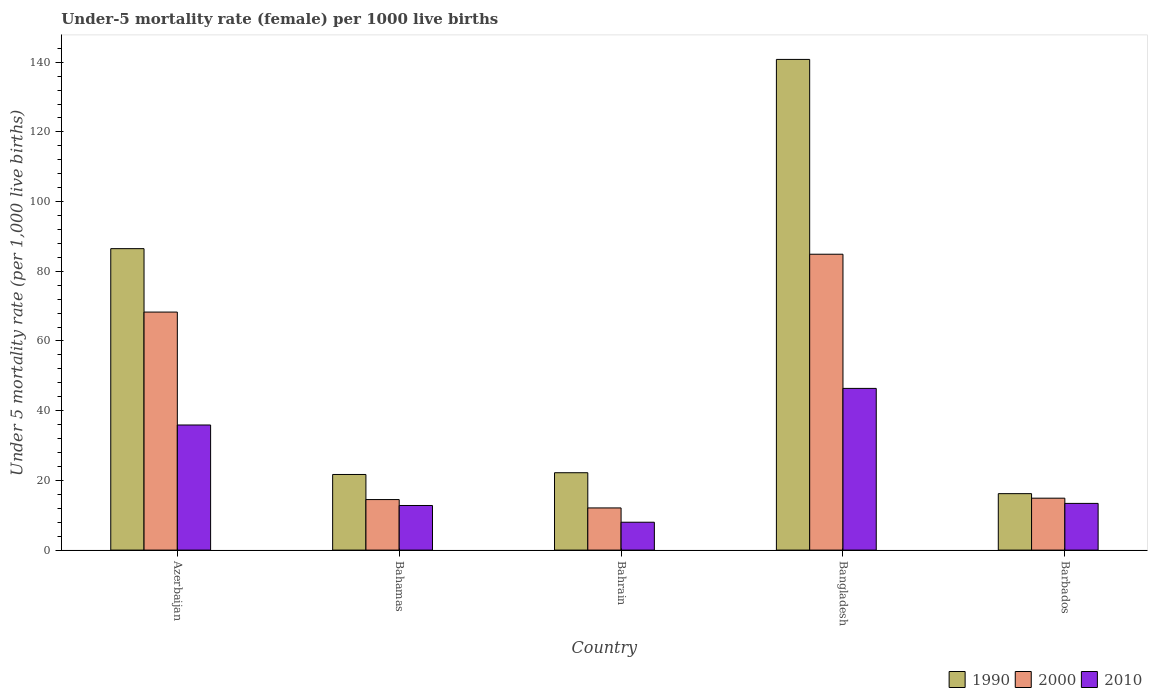How many different coloured bars are there?
Your answer should be compact. 3. How many groups of bars are there?
Your response must be concise. 5. What is the label of the 4th group of bars from the left?
Make the answer very short. Bangladesh. What is the under-five mortality rate in 2000 in Bahrain?
Offer a very short reply. 12.1. Across all countries, what is the maximum under-five mortality rate in 2010?
Make the answer very short. 46.4. In which country was the under-five mortality rate in 1990 maximum?
Your answer should be compact. Bangladesh. In which country was the under-five mortality rate in 1990 minimum?
Provide a succinct answer. Barbados. What is the total under-five mortality rate in 2000 in the graph?
Your answer should be compact. 194.7. What is the difference between the under-five mortality rate in 2010 in Bahamas and that in Bahrain?
Your answer should be very brief. 4.8. What is the difference between the under-five mortality rate in 2010 in Barbados and the under-five mortality rate in 2000 in Bangladesh?
Offer a very short reply. -71.5. What is the average under-five mortality rate in 2010 per country?
Your answer should be very brief. 23.3. What is the difference between the under-five mortality rate of/in 2000 and under-five mortality rate of/in 1990 in Barbados?
Offer a terse response. -1.3. In how many countries, is the under-five mortality rate in 2000 greater than 64?
Give a very brief answer. 2. What is the ratio of the under-five mortality rate in 2000 in Azerbaijan to that in Bahamas?
Make the answer very short. 4.71. What is the difference between the highest and the second highest under-five mortality rate in 2010?
Offer a very short reply. 22.5. What is the difference between the highest and the lowest under-five mortality rate in 2000?
Offer a very short reply. 72.8. Is the sum of the under-five mortality rate in 2010 in Bahrain and Bangladesh greater than the maximum under-five mortality rate in 2000 across all countries?
Your answer should be compact. No. What does the 3rd bar from the left in Bahrain represents?
Keep it short and to the point. 2010. Is it the case that in every country, the sum of the under-five mortality rate in 2010 and under-five mortality rate in 2000 is greater than the under-five mortality rate in 1990?
Your answer should be very brief. No. Are all the bars in the graph horizontal?
Your answer should be compact. No. How many countries are there in the graph?
Your answer should be very brief. 5. Are the values on the major ticks of Y-axis written in scientific E-notation?
Provide a short and direct response. No. Where does the legend appear in the graph?
Keep it short and to the point. Bottom right. How are the legend labels stacked?
Your response must be concise. Horizontal. What is the title of the graph?
Offer a terse response. Under-5 mortality rate (female) per 1000 live births. Does "1983" appear as one of the legend labels in the graph?
Offer a terse response. No. What is the label or title of the X-axis?
Your answer should be very brief. Country. What is the label or title of the Y-axis?
Make the answer very short. Under 5 mortality rate (per 1,0 live births). What is the Under 5 mortality rate (per 1,000 live births) in 1990 in Azerbaijan?
Provide a succinct answer. 86.5. What is the Under 5 mortality rate (per 1,000 live births) of 2000 in Azerbaijan?
Your answer should be compact. 68.3. What is the Under 5 mortality rate (per 1,000 live births) of 2010 in Azerbaijan?
Your response must be concise. 35.9. What is the Under 5 mortality rate (per 1,000 live births) in 1990 in Bahamas?
Your answer should be very brief. 21.7. What is the Under 5 mortality rate (per 1,000 live births) in 1990 in Bahrain?
Offer a terse response. 22.2. What is the Under 5 mortality rate (per 1,000 live births) of 2000 in Bahrain?
Your answer should be compact. 12.1. What is the Under 5 mortality rate (per 1,000 live births) in 2010 in Bahrain?
Give a very brief answer. 8. What is the Under 5 mortality rate (per 1,000 live births) in 1990 in Bangladesh?
Your answer should be very brief. 140.8. What is the Under 5 mortality rate (per 1,000 live births) in 2000 in Bangladesh?
Your response must be concise. 84.9. What is the Under 5 mortality rate (per 1,000 live births) of 2010 in Bangladesh?
Your response must be concise. 46.4. What is the Under 5 mortality rate (per 1,000 live births) in 1990 in Barbados?
Keep it short and to the point. 16.2. What is the Under 5 mortality rate (per 1,000 live births) in 2010 in Barbados?
Offer a very short reply. 13.4. Across all countries, what is the maximum Under 5 mortality rate (per 1,000 live births) in 1990?
Your answer should be very brief. 140.8. Across all countries, what is the maximum Under 5 mortality rate (per 1,000 live births) of 2000?
Ensure brevity in your answer.  84.9. Across all countries, what is the maximum Under 5 mortality rate (per 1,000 live births) in 2010?
Your answer should be compact. 46.4. Across all countries, what is the minimum Under 5 mortality rate (per 1,000 live births) of 1990?
Keep it short and to the point. 16.2. What is the total Under 5 mortality rate (per 1,000 live births) of 1990 in the graph?
Keep it short and to the point. 287.4. What is the total Under 5 mortality rate (per 1,000 live births) of 2000 in the graph?
Offer a terse response. 194.7. What is the total Under 5 mortality rate (per 1,000 live births) of 2010 in the graph?
Ensure brevity in your answer.  116.5. What is the difference between the Under 5 mortality rate (per 1,000 live births) of 1990 in Azerbaijan and that in Bahamas?
Your response must be concise. 64.8. What is the difference between the Under 5 mortality rate (per 1,000 live births) of 2000 in Azerbaijan and that in Bahamas?
Your response must be concise. 53.8. What is the difference between the Under 5 mortality rate (per 1,000 live births) of 2010 in Azerbaijan and that in Bahamas?
Ensure brevity in your answer.  23.1. What is the difference between the Under 5 mortality rate (per 1,000 live births) of 1990 in Azerbaijan and that in Bahrain?
Offer a terse response. 64.3. What is the difference between the Under 5 mortality rate (per 1,000 live births) of 2000 in Azerbaijan and that in Bahrain?
Provide a short and direct response. 56.2. What is the difference between the Under 5 mortality rate (per 1,000 live births) in 2010 in Azerbaijan and that in Bahrain?
Offer a very short reply. 27.9. What is the difference between the Under 5 mortality rate (per 1,000 live births) in 1990 in Azerbaijan and that in Bangladesh?
Keep it short and to the point. -54.3. What is the difference between the Under 5 mortality rate (per 1,000 live births) of 2000 in Azerbaijan and that in Bangladesh?
Provide a short and direct response. -16.6. What is the difference between the Under 5 mortality rate (per 1,000 live births) in 1990 in Azerbaijan and that in Barbados?
Your answer should be very brief. 70.3. What is the difference between the Under 5 mortality rate (per 1,000 live births) in 2000 in Azerbaijan and that in Barbados?
Your answer should be very brief. 53.4. What is the difference between the Under 5 mortality rate (per 1,000 live births) in 1990 in Bahamas and that in Bangladesh?
Provide a succinct answer. -119.1. What is the difference between the Under 5 mortality rate (per 1,000 live births) of 2000 in Bahamas and that in Bangladesh?
Give a very brief answer. -70.4. What is the difference between the Under 5 mortality rate (per 1,000 live births) of 2010 in Bahamas and that in Bangladesh?
Make the answer very short. -33.6. What is the difference between the Under 5 mortality rate (per 1,000 live births) in 1990 in Bahamas and that in Barbados?
Your response must be concise. 5.5. What is the difference between the Under 5 mortality rate (per 1,000 live births) of 2000 in Bahamas and that in Barbados?
Offer a terse response. -0.4. What is the difference between the Under 5 mortality rate (per 1,000 live births) in 2010 in Bahamas and that in Barbados?
Make the answer very short. -0.6. What is the difference between the Under 5 mortality rate (per 1,000 live births) in 1990 in Bahrain and that in Bangladesh?
Ensure brevity in your answer.  -118.6. What is the difference between the Under 5 mortality rate (per 1,000 live births) in 2000 in Bahrain and that in Bangladesh?
Your answer should be compact. -72.8. What is the difference between the Under 5 mortality rate (per 1,000 live births) of 2010 in Bahrain and that in Bangladesh?
Keep it short and to the point. -38.4. What is the difference between the Under 5 mortality rate (per 1,000 live births) in 1990 in Bahrain and that in Barbados?
Make the answer very short. 6. What is the difference between the Under 5 mortality rate (per 1,000 live births) of 2010 in Bahrain and that in Barbados?
Keep it short and to the point. -5.4. What is the difference between the Under 5 mortality rate (per 1,000 live births) of 1990 in Bangladesh and that in Barbados?
Your answer should be very brief. 124.6. What is the difference between the Under 5 mortality rate (per 1,000 live births) of 2000 in Bangladesh and that in Barbados?
Your answer should be compact. 70. What is the difference between the Under 5 mortality rate (per 1,000 live births) in 1990 in Azerbaijan and the Under 5 mortality rate (per 1,000 live births) in 2000 in Bahamas?
Offer a very short reply. 72. What is the difference between the Under 5 mortality rate (per 1,000 live births) of 1990 in Azerbaijan and the Under 5 mortality rate (per 1,000 live births) of 2010 in Bahamas?
Provide a succinct answer. 73.7. What is the difference between the Under 5 mortality rate (per 1,000 live births) of 2000 in Azerbaijan and the Under 5 mortality rate (per 1,000 live births) of 2010 in Bahamas?
Provide a short and direct response. 55.5. What is the difference between the Under 5 mortality rate (per 1,000 live births) in 1990 in Azerbaijan and the Under 5 mortality rate (per 1,000 live births) in 2000 in Bahrain?
Make the answer very short. 74.4. What is the difference between the Under 5 mortality rate (per 1,000 live births) in 1990 in Azerbaijan and the Under 5 mortality rate (per 1,000 live births) in 2010 in Bahrain?
Your response must be concise. 78.5. What is the difference between the Under 5 mortality rate (per 1,000 live births) of 2000 in Azerbaijan and the Under 5 mortality rate (per 1,000 live births) of 2010 in Bahrain?
Keep it short and to the point. 60.3. What is the difference between the Under 5 mortality rate (per 1,000 live births) in 1990 in Azerbaijan and the Under 5 mortality rate (per 1,000 live births) in 2010 in Bangladesh?
Make the answer very short. 40.1. What is the difference between the Under 5 mortality rate (per 1,000 live births) of 2000 in Azerbaijan and the Under 5 mortality rate (per 1,000 live births) of 2010 in Bangladesh?
Your response must be concise. 21.9. What is the difference between the Under 5 mortality rate (per 1,000 live births) in 1990 in Azerbaijan and the Under 5 mortality rate (per 1,000 live births) in 2000 in Barbados?
Ensure brevity in your answer.  71.6. What is the difference between the Under 5 mortality rate (per 1,000 live births) in 1990 in Azerbaijan and the Under 5 mortality rate (per 1,000 live births) in 2010 in Barbados?
Your answer should be very brief. 73.1. What is the difference between the Under 5 mortality rate (per 1,000 live births) in 2000 in Azerbaijan and the Under 5 mortality rate (per 1,000 live births) in 2010 in Barbados?
Give a very brief answer. 54.9. What is the difference between the Under 5 mortality rate (per 1,000 live births) in 1990 in Bahamas and the Under 5 mortality rate (per 1,000 live births) in 2000 in Bahrain?
Give a very brief answer. 9.6. What is the difference between the Under 5 mortality rate (per 1,000 live births) of 1990 in Bahamas and the Under 5 mortality rate (per 1,000 live births) of 2000 in Bangladesh?
Your response must be concise. -63.2. What is the difference between the Under 5 mortality rate (per 1,000 live births) of 1990 in Bahamas and the Under 5 mortality rate (per 1,000 live births) of 2010 in Bangladesh?
Your answer should be very brief. -24.7. What is the difference between the Under 5 mortality rate (per 1,000 live births) in 2000 in Bahamas and the Under 5 mortality rate (per 1,000 live births) in 2010 in Bangladesh?
Your answer should be compact. -31.9. What is the difference between the Under 5 mortality rate (per 1,000 live births) of 1990 in Bahamas and the Under 5 mortality rate (per 1,000 live births) of 2000 in Barbados?
Your answer should be very brief. 6.8. What is the difference between the Under 5 mortality rate (per 1,000 live births) of 2000 in Bahamas and the Under 5 mortality rate (per 1,000 live births) of 2010 in Barbados?
Ensure brevity in your answer.  1.1. What is the difference between the Under 5 mortality rate (per 1,000 live births) in 1990 in Bahrain and the Under 5 mortality rate (per 1,000 live births) in 2000 in Bangladesh?
Your answer should be very brief. -62.7. What is the difference between the Under 5 mortality rate (per 1,000 live births) in 1990 in Bahrain and the Under 5 mortality rate (per 1,000 live births) in 2010 in Bangladesh?
Keep it short and to the point. -24.2. What is the difference between the Under 5 mortality rate (per 1,000 live births) of 2000 in Bahrain and the Under 5 mortality rate (per 1,000 live births) of 2010 in Bangladesh?
Make the answer very short. -34.3. What is the difference between the Under 5 mortality rate (per 1,000 live births) of 1990 in Bahrain and the Under 5 mortality rate (per 1,000 live births) of 2000 in Barbados?
Ensure brevity in your answer.  7.3. What is the difference between the Under 5 mortality rate (per 1,000 live births) in 1990 in Bahrain and the Under 5 mortality rate (per 1,000 live births) in 2010 in Barbados?
Offer a very short reply. 8.8. What is the difference between the Under 5 mortality rate (per 1,000 live births) of 1990 in Bangladesh and the Under 5 mortality rate (per 1,000 live births) of 2000 in Barbados?
Provide a succinct answer. 125.9. What is the difference between the Under 5 mortality rate (per 1,000 live births) of 1990 in Bangladesh and the Under 5 mortality rate (per 1,000 live births) of 2010 in Barbados?
Offer a terse response. 127.4. What is the difference between the Under 5 mortality rate (per 1,000 live births) in 2000 in Bangladesh and the Under 5 mortality rate (per 1,000 live births) in 2010 in Barbados?
Keep it short and to the point. 71.5. What is the average Under 5 mortality rate (per 1,000 live births) in 1990 per country?
Make the answer very short. 57.48. What is the average Under 5 mortality rate (per 1,000 live births) in 2000 per country?
Your response must be concise. 38.94. What is the average Under 5 mortality rate (per 1,000 live births) of 2010 per country?
Provide a short and direct response. 23.3. What is the difference between the Under 5 mortality rate (per 1,000 live births) of 1990 and Under 5 mortality rate (per 1,000 live births) of 2010 in Azerbaijan?
Offer a very short reply. 50.6. What is the difference between the Under 5 mortality rate (per 1,000 live births) in 2000 and Under 5 mortality rate (per 1,000 live births) in 2010 in Azerbaijan?
Provide a short and direct response. 32.4. What is the difference between the Under 5 mortality rate (per 1,000 live births) of 1990 and Under 5 mortality rate (per 1,000 live births) of 2000 in Bahamas?
Your response must be concise. 7.2. What is the difference between the Under 5 mortality rate (per 1,000 live births) of 1990 and Under 5 mortality rate (per 1,000 live births) of 2010 in Bahamas?
Provide a succinct answer. 8.9. What is the difference between the Under 5 mortality rate (per 1,000 live births) in 2000 and Under 5 mortality rate (per 1,000 live births) in 2010 in Bahamas?
Provide a succinct answer. 1.7. What is the difference between the Under 5 mortality rate (per 1,000 live births) in 1990 and Under 5 mortality rate (per 1,000 live births) in 2010 in Bahrain?
Ensure brevity in your answer.  14.2. What is the difference between the Under 5 mortality rate (per 1,000 live births) of 2000 and Under 5 mortality rate (per 1,000 live births) of 2010 in Bahrain?
Offer a terse response. 4.1. What is the difference between the Under 5 mortality rate (per 1,000 live births) of 1990 and Under 5 mortality rate (per 1,000 live births) of 2000 in Bangladesh?
Offer a very short reply. 55.9. What is the difference between the Under 5 mortality rate (per 1,000 live births) in 1990 and Under 5 mortality rate (per 1,000 live births) in 2010 in Bangladesh?
Offer a very short reply. 94.4. What is the difference between the Under 5 mortality rate (per 1,000 live births) of 2000 and Under 5 mortality rate (per 1,000 live births) of 2010 in Bangladesh?
Your answer should be very brief. 38.5. What is the difference between the Under 5 mortality rate (per 1,000 live births) in 1990 and Under 5 mortality rate (per 1,000 live births) in 2010 in Barbados?
Make the answer very short. 2.8. What is the ratio of the Under 5 mortality rate (per 1,000 live births) in 1990 in Azerbaijan to that in Bahamas?
Your response must be concise. 3.99. What is the ratio of the Under 5 mortality rate (per 1,000 live births) in 2000 in Azerbaijan to that in Bahamas?
Offer a very short reply. 4.71. What is the ratio of the Under 5 mortality rate (per 1,000 live births) of 2010 in Azerbaijan to that in Bahamas?
Make the answer very short. 2.8. What is the ratio of the Under 5 mortality rate (per 1,000 live births) of 1990 in Azerbaijan to that in Bahrain?
Give a very brief answer. 3.9. What is the ratio of the Under 5 mortality rate (per 1,000 live births) of 2000 in Azerbaijan to that in Bahrain?
Give a very brief answer. 5.64. What is the ratio of the Under 5 mortality rate (per 1,000 live births) in 2010 in Azerbaijan to that in Bahrain?
Keep it short and to the point. 4.49. What is the ratio of the Under 5 mortality rate (per 1,000 live births) of 1990 in Azerbaijan to that in Bangladesh?
Provide a short and direct response. 0.61. What is the ratio of the Under 5 mortality rate (per 1,000 live births) of 2000 in Azerbaijan to that in Bangladesh?
Your answer should be very brief. 0.8. What is the ratio of the Under 5 mortality rate (per 1,000 live births) of 2010 in Azerbaijan to that in Bangladesh?
Offer a very short reply. 0.77. What is the ratio of the Under 5 mortality rate (per 1,000 live births) in 1990 in Azerbaijan to that in Barbados?
Your response must be concise. 5.34. What is the ratio of the Under 5 mortality rate (per 1,000 live births) in 2000 in Azerbaijan to that in Barbados?
Your response must be concise. 4.58. What is the ratio of the Under 5 mortality rate (per 1,000 live births) of 2010 in Azerbaijan to that in Barbados?
Your response must be concise. 2.68. What is the ratio of the Under 5 mortality rate (per 1,000 live births) in 1990 in Bahamas to that in Bahrain?
Ensure brevity in your answer.  0.98. What is the ratio of the Under 5 mortality rate (per 1,000 live births) of 2000 in Bahamas to that in Bahrain?
Give a very brief answer. 1.2. What is the ratio of the Under 5 mortality rate (per 1,000 live births) in 2010 in Bahamas to that in Bahrain?
Offer a terse response. 1.6. What is the ratio of the Under 5 mortality rate (per 1,000 live births) in 1990 in Bahamas to that in Bangladesh?
Keep it short and to the point. 0.15. What is the ratio of the Under 5 mortality rate (per 1,000 live births) in 2000 in Bahamas to that in Bangladesh?
Ensure brevity in your answer.  0.17. What is the ratio of the Under 5 mortality rate (per 1,000 live births) of 2010 in Bahamas to that in Bangladesh?
Give a very brief answer. 0.28. What is the ratio of the Under 5 mortality rate (per 1,000 live births) in 1990 in Bahamas to that in Barbados?
Offer a terse response. 1.34. What is the ratio of the Under 5 mortality rate (per 1,000 live births) of 2000 in Bahamas to that in Barbados?
Your response must be concise. 0.97. What is the ratio of the Under 5 mortality rate (per 1,000 live births) of 2010 in Bahamas to that in Barbados?
Make the answer very short. 0.96. What is the ratio of the Under 5 mortality rate (per 1,000 live births) of 1990 in Bahrain to that in Bangladesh?
Offer a terse response. 0.16. What is the ratio of the Under 5 mortality rate (per 1,000 live births) in 2000 in Bahrain to that in Bangladesh?
Provide a succinct answer. 0.14. What is the ratio of the Under 5 mortality rate (per 1,000 live births) of 2010 in Bahrain to that in Bangladesh?
Offer a terse response. 0.17. What is the ratio of the Under 5 mortality rate (per 1,000 live births) of 1990 in Bahrain to that in Barbados?
Keep it short and to the point. 1.37. What is the ratio of the Under 5 mortality rate (per 1,000 live births) in 2000 in Bahrain to that in Barbados?
Keep it short and to the point. 0.81. What is the ratio of the Under 5 mortality rate (per 1,000 live births) in 2010 in Bahrain to that in Barbados?
Your answer should be compact. 0.6. What is the ratio of the Under 5 mortality rate (per 1,000 live births) of 1990 in Bangladesh to that in Barbados?
Provide a succinct answer. 8.69. What is the ratio of the Under 5 mortality rate (per 1,000 live births) of 2000 in Bangladesh to that in Barbados?
Keep it short and to the point. 5.7. What is the ratio of the Under 5 mortality rate (per 1,000 live births) in 2010 in Bangladesh to that in Barbados?
Make the answer very short. 3.46. What is the difference between the highest and the second highest Under 5 mortality rate (per 1,000 live births) of 1990?
Your answer should be compact. 54.3. What is the difference between the highest and the second highest Under 5 mortality rate (per 1,000 live births) of 2000?
Give a very brief answer. 16.6. What is the difference between the highest and the second highest Under 5 mortality rate (per 1,000 live births) of 2010?
Keep it short and to the point. 10.5. What is the difference between the highest and the lowest Under 5 mortality rate (per 1,000 live births) of 1990?
Give a very brief answer. 124.6. What is the difference between the highest and the lowest Under 5 mortality rate (per 1,000 live births) in 2000?
Your answer should be very brief. 72.8. What is the difference between the highest and the lowest Under 5 mortality rate (per 1,000 live births) in 2010?
Provide a short and direct response. 38.4. 